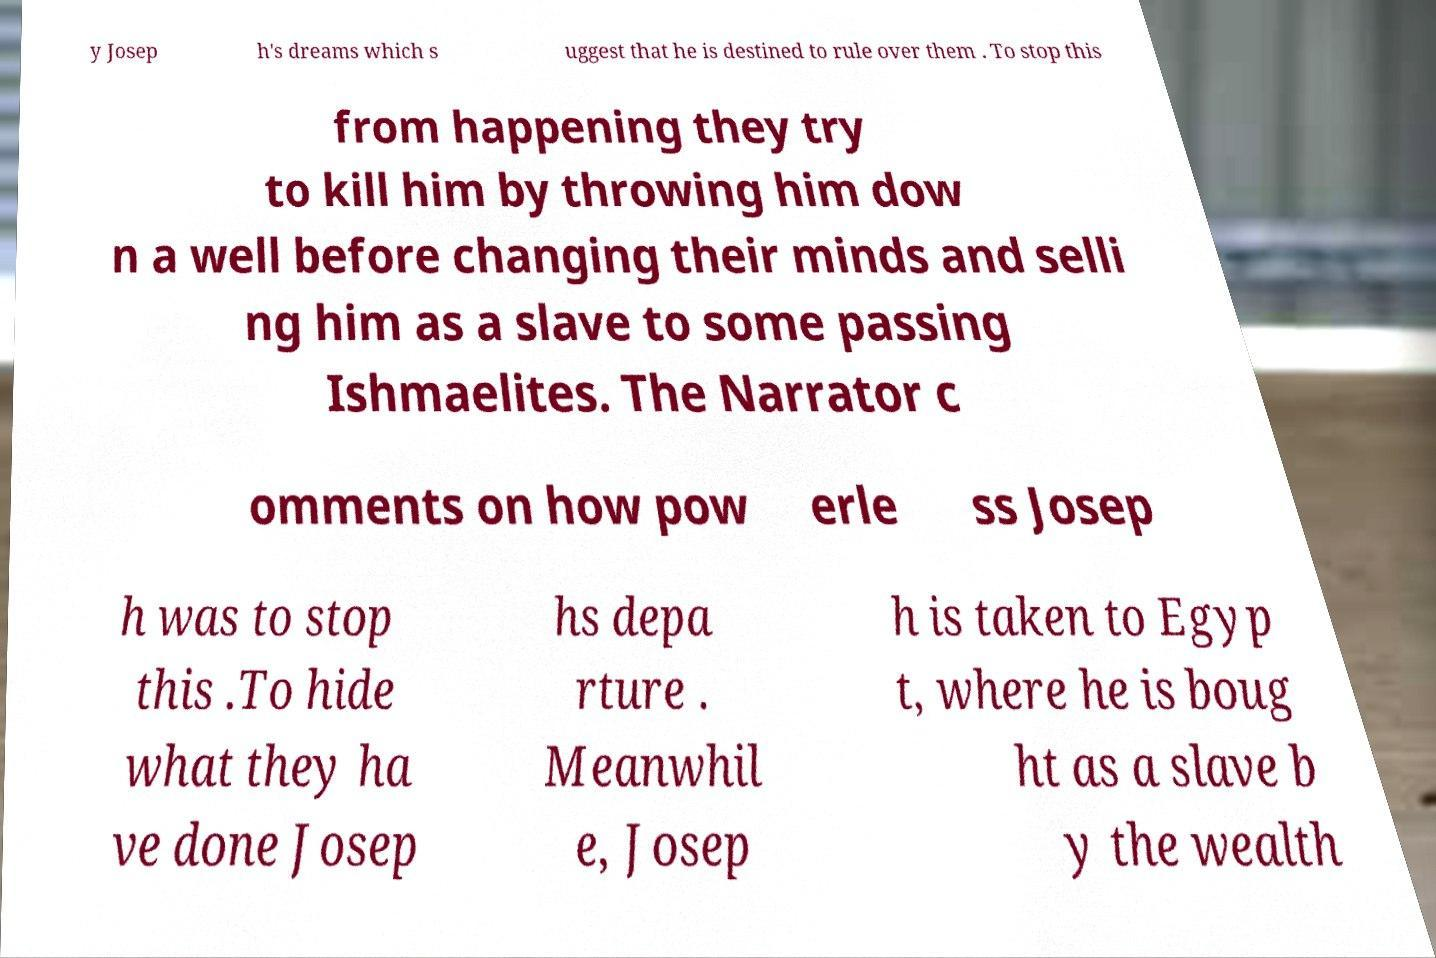For documentation purposes, I need the text within this image transcribed. Could you provide that? y Josep h's dreams which s uggest that he is destined to rule over them . To stop this from happening they try to kill him by throwing him dow n a well before changing their minds and selli ng him as a slave to some passing Ishmaelites. The Narrator c omments on how pow erle ss Josep h was to stop this .To hide what they ha ve done Josep hs depa rture . Meanwhil e, Josep h is taken to Egyp t, where he is boug ht as a slave b y the wealth 